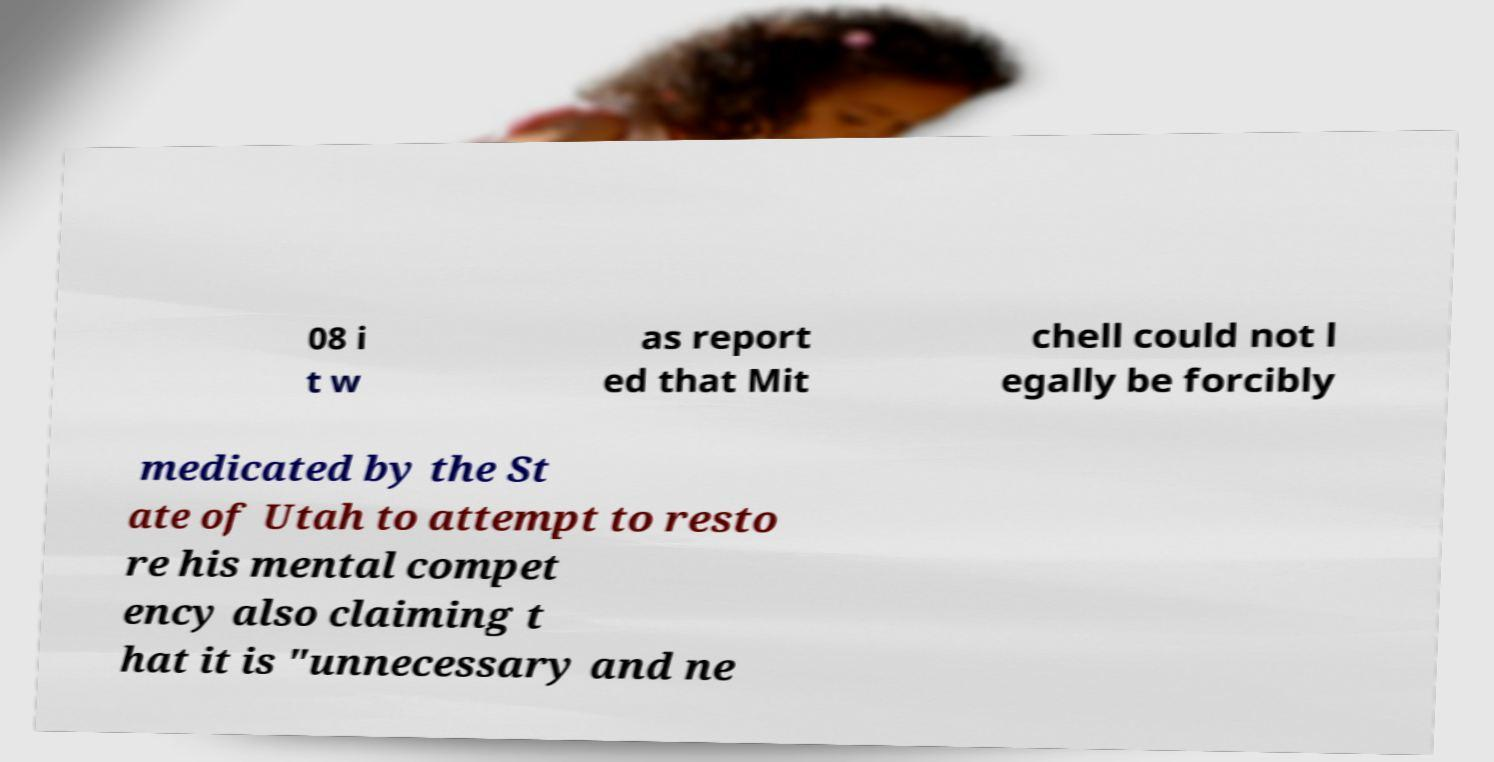For documentation purposes, I need the text within this image transcribed. Could you provide that? 08 i t w as report ed that Mit chell could not l egally be forcibly medicated by the St ate of Utah to attempt to resto re his mental compet ency also claiming t hat it is "unnecessary and ne 